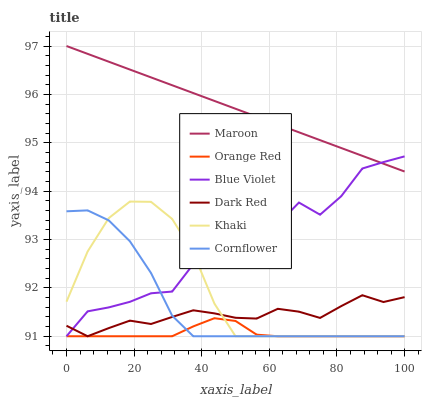Does Orange Red have the minimum area under the curve?
Answer yes or no. Yes. Does Maroon have the maximum area under the curve?
Answer yes or no. Yes. Does Khaki have the minimum area under the curve?
Answer yes or no. No. Does Khaki have the maximum area under the curve?
Answer yes or no. No. Is Maroon the smoothest?
Answer yes or no. Yes. Is Blue Violet the roughest?
Answer yes or no. Yes. Is Khaki the smoothest?
Answer yes or no. No. Is Khaki the roughest?
Answer yes or no. No. Does Cornflower have the lowest value?
Answer yes or no. Yes. Does Maroon have the lowest value?
Answer yes or no. No. Does Maroon have the highest value?
Answer yes or no. Yes. Does Khaki have the highest value?
Answer yes or no. No. Is Khaki less than Maroon?
Answer yes or no. Yes. Is Maroon greater than Cornflower?
Answer yes or no. Yes. Does Blue Violet intersect Khaki?
Answer yes or no. Yes. Is Blue Violet less than Khaki?
Answer yes or no. No. Is Blue Violet greater than Khaki?
Answer yes or no. No. Does Khaki intersect Maroon?
Answer yes or no. No. 